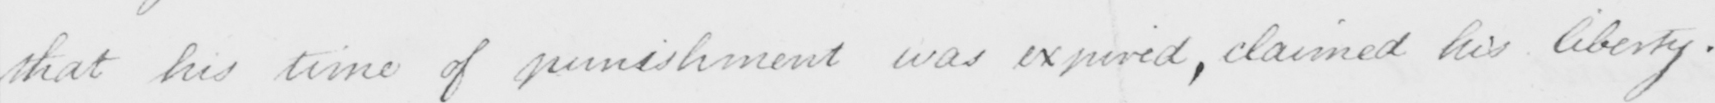What text is written in this handwritten line? that his time of punishment was expired , claimed his liberty . 